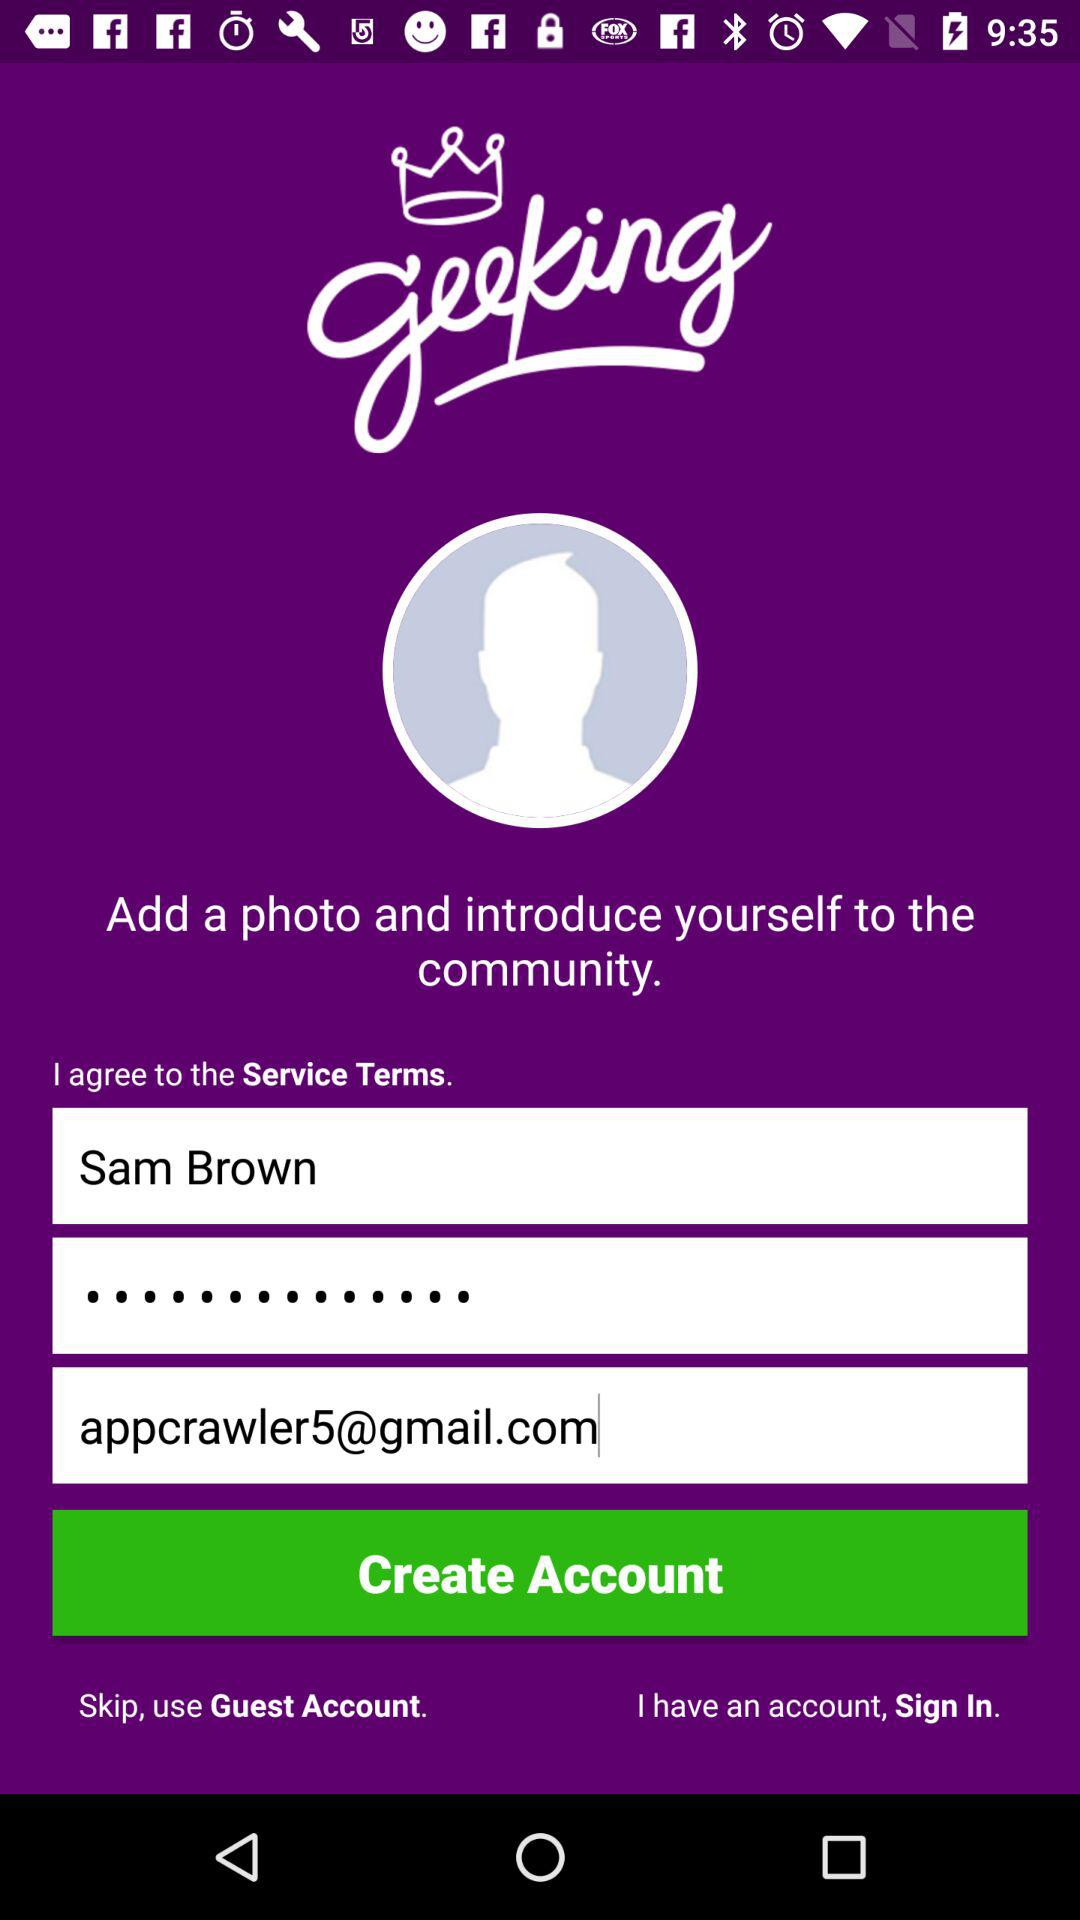What is the name of the user? The name of the user is Sam Brown. 